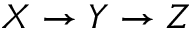<formula> <loc_0><loc_0><loc_500><loc_500>X \rightarrow Y \rightarrow Z</formula> 